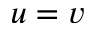Convert formula to latex. <formula><loc_0><loc_0><loc_500><loc_500>u = v</formula> 